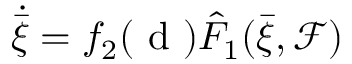<formula> <loc_0><loc_0><loc_500><loc_500>\dot { \bar { \xi } } = f _ { 2 } ( d ) \hat { F } _ { 1 } ( \bar { \xi } , \mathcal { F } )</formula> 